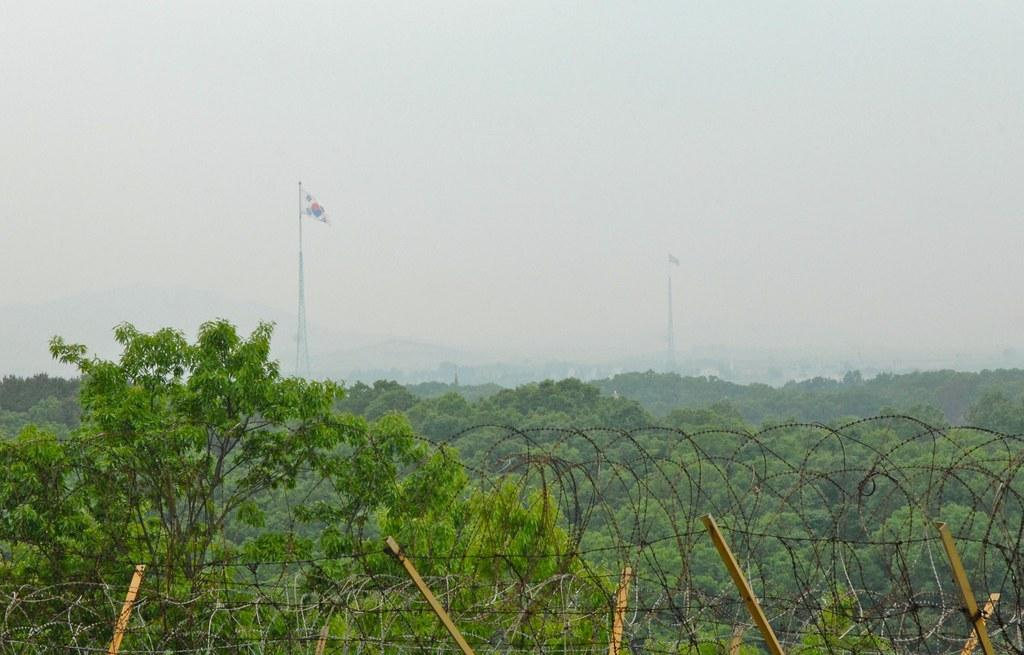What type of natural elements can be seen in the image? There are trees in the image. What man-made structures are present in the image? There is fencing in the image. What additional objects can be seen in the image? There are flags in the image. What is the color of the sky in the image? The sky appears to be white in color. Can you tell me how many girls are playing with lumber in the image? There are no girls or lumber present in the image. 